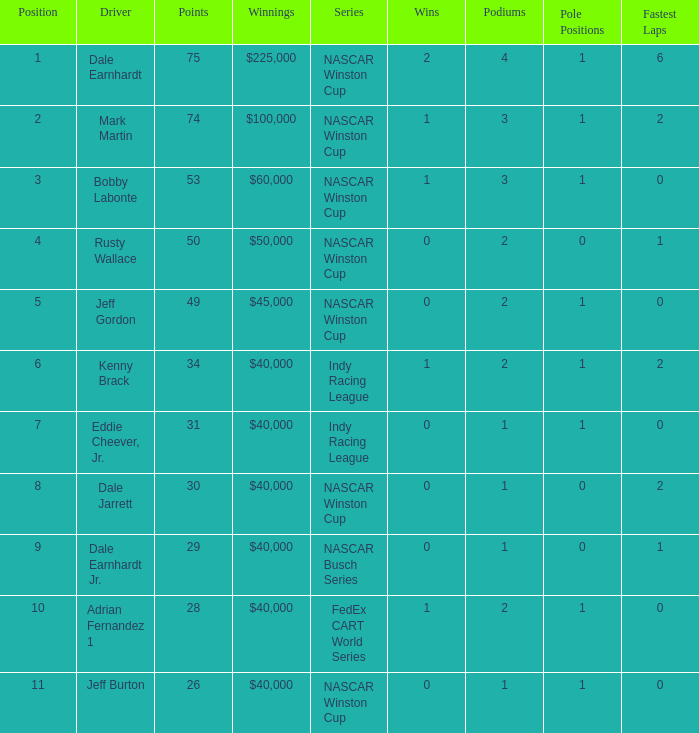In what series did Bobby Labonte drive? NASCAR Winston Cup. 